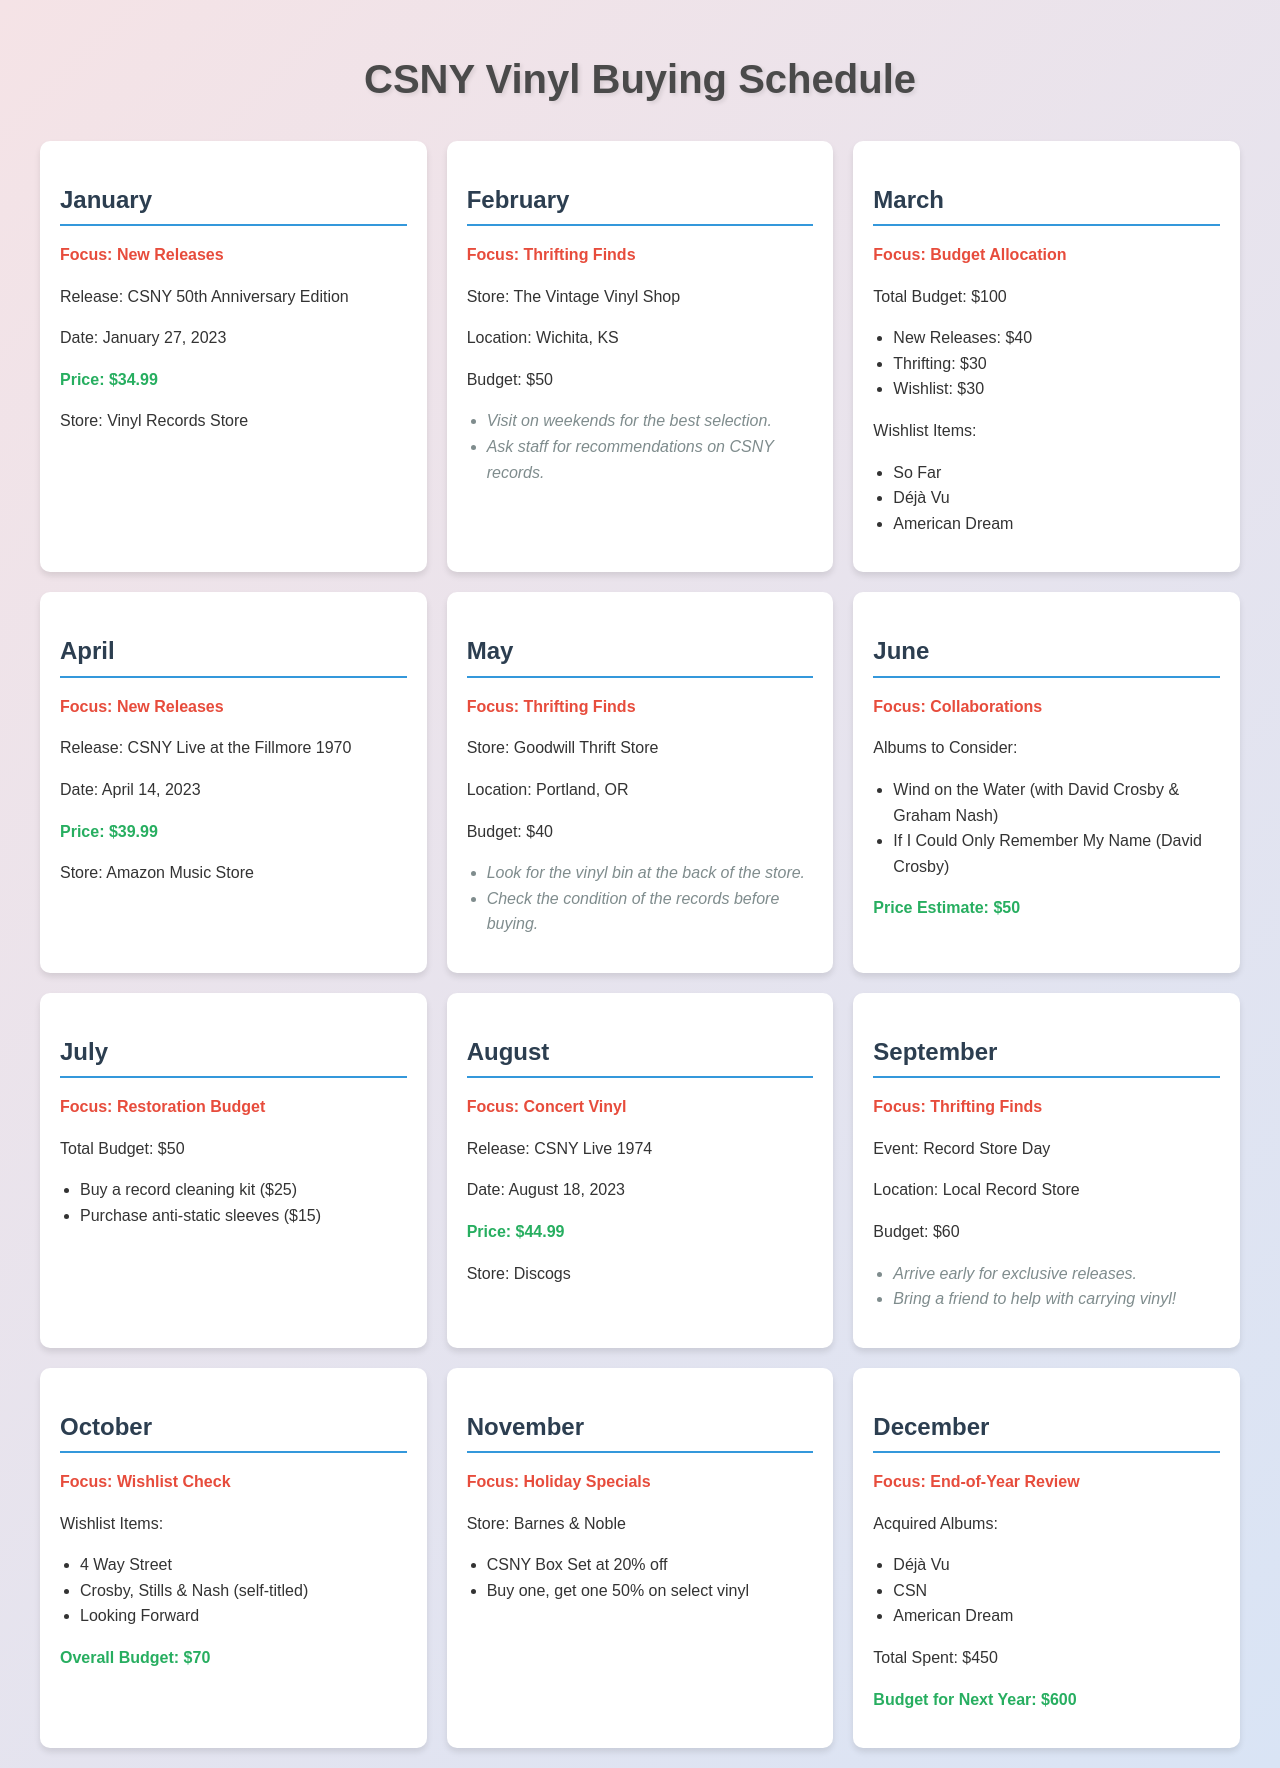what is the release date for the CSNY 50th Anniversary Edition? The release date for the CSNY 50th Anniversary Edition is mentioned in January's section, which is January 27, 2023.
Answer: January 27, 2023 what is the total budget for March? The total budget for March is specified in the monthly budget section under "Budget Allocation".
Answer: $100 which store is focused on for thifting finds in February? The store designated for thrifting finds in February is stated in the month-card for February.
Answer: The Vintage Vinyl Shop what albums are included in the wishlist for March? The wishlist items are listed in the section for March, detailing specific albums desired for acquisition.
Answer: So Far, Déjà Vu, American Dream what is the price for the CSNY Live at the Fillmore 1970? The price for the CSNY Live at the Fillmore 1970 album is included in April’s section.
Answer: $39.99 how much money is allocated for thifting in March? The allocation for thifting in March is detailed as part of the budget breakdown provided.
Answer: $30 what is the budget for December's end-of-year review? The budget stated for December under end-of-year review indicates future spending plans.
Answer: $600 when is the Record Store Day event? The month in which the Record Store Day event occurs is highlighted under September's information.
Answer: September which month focuses on collaborations? The month designated for focusing on collaborations is indicated explicitly in the document.
Answer: June what is the price of the CSNY Live 1974 album? The price of the CSNY Live 1974 album can be found in the respective section focused on concert vinyl releases.
Answer: $44.99 